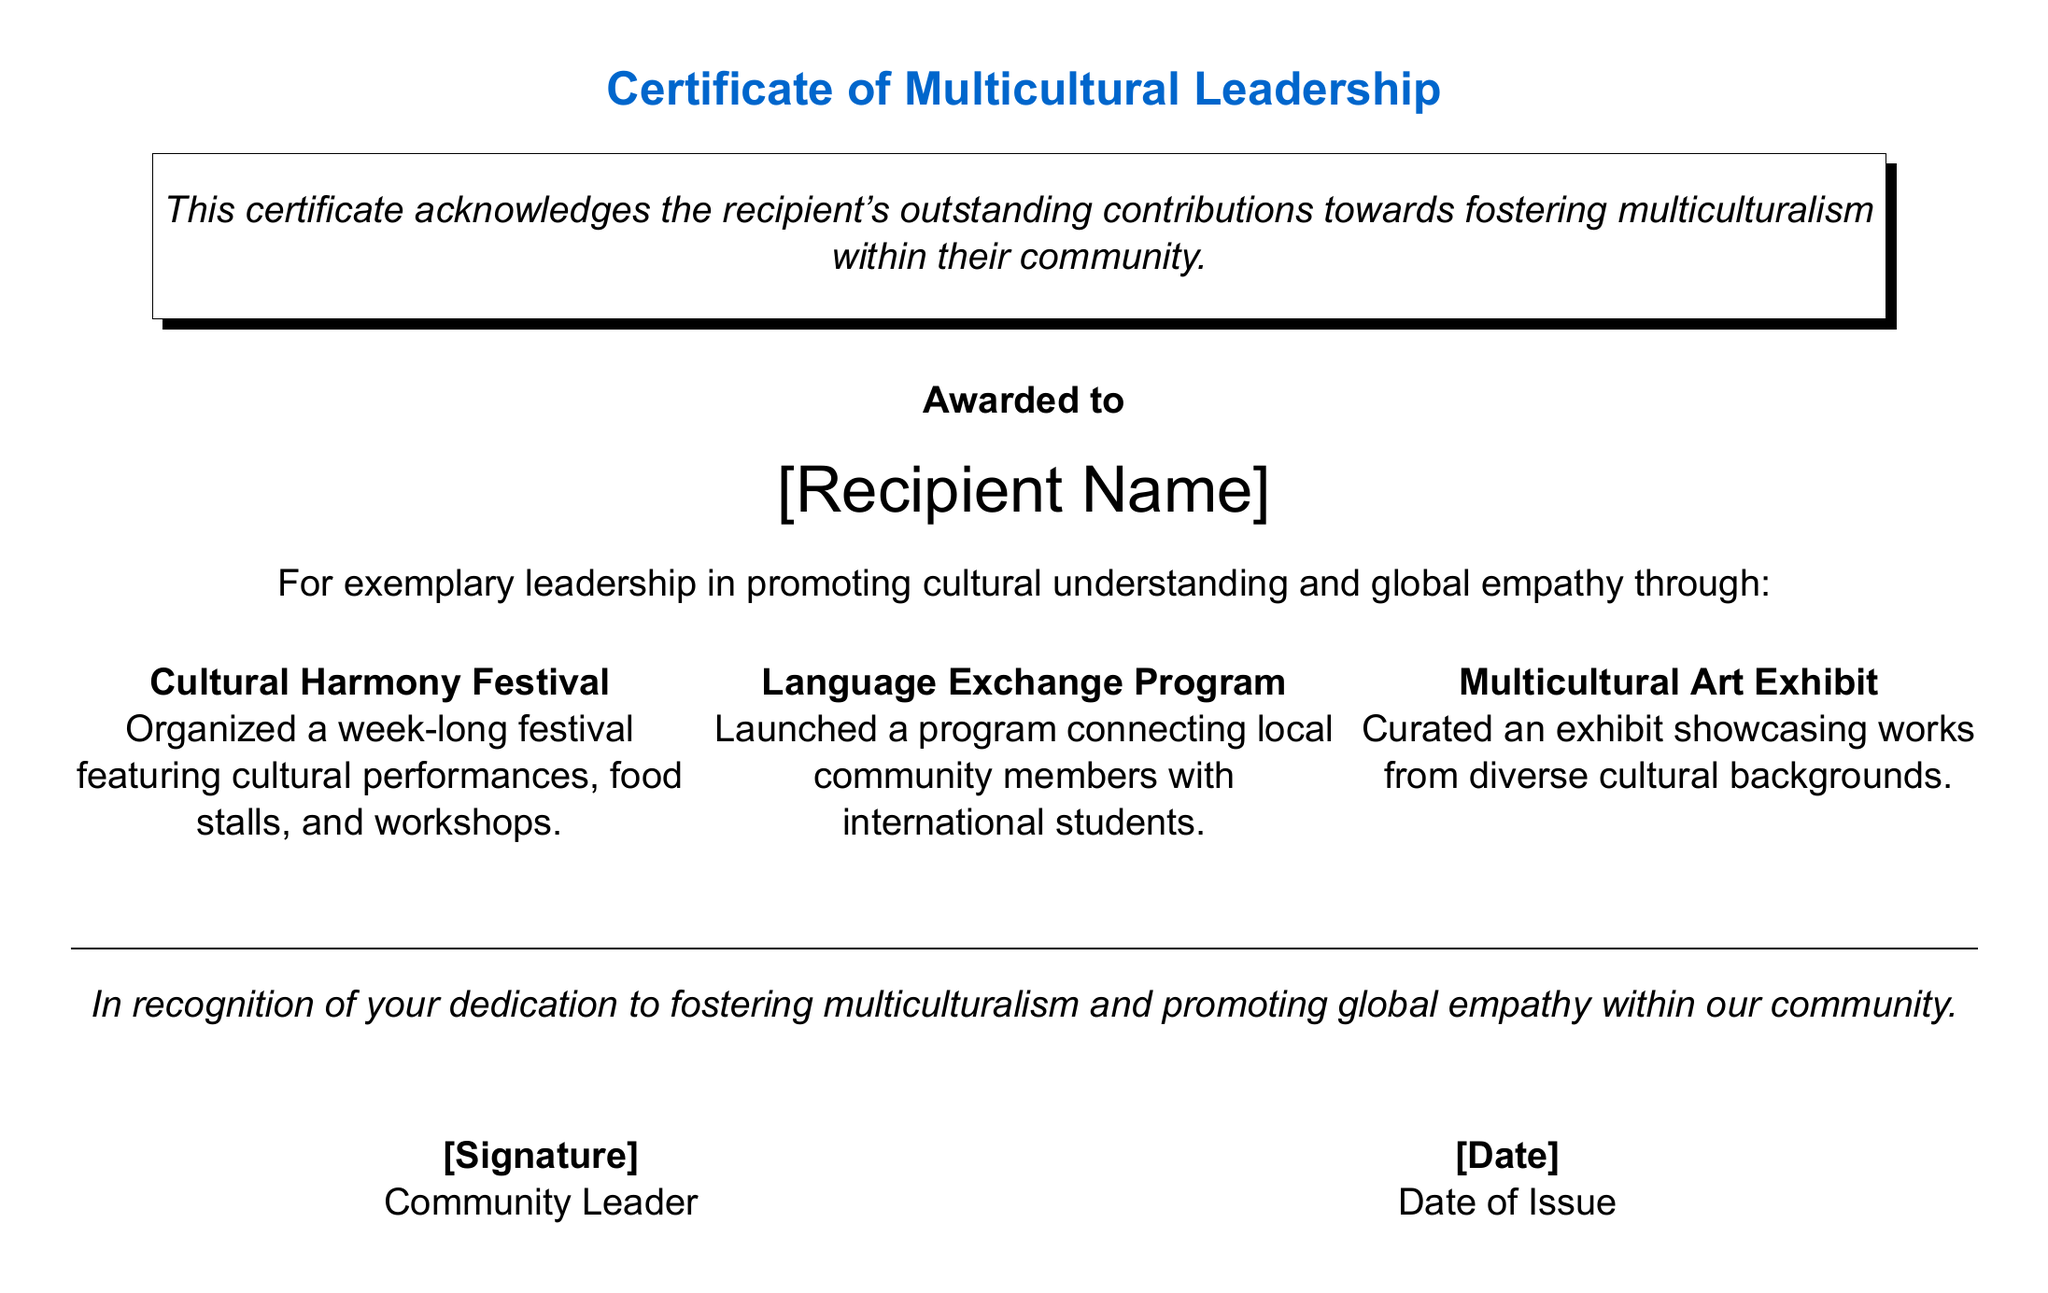What is the title of the certificate? The title is stated at the top of the certificate as "Certificate of Multicultural Leadership."
Answer: Certificate of Multicultural Leadership Who is the recipient of this certificate? The recipient's name is to be filled in the designated area marked as "[Recipient Name]."
Answer: [Recipient Name] What is one event mentioned in the contributions? The document lists several contributions, one of which is the "Cultural Harmony Festival."
Answer: Cultural Harmony Festival What is the purpose of the certificate? The certificate acknowledges contributions towards fostering multiculturalism within the community.
Answer: Fostering multiculturalism Who awards the certificate? The certificate is awarded by a person referred to as "Community Leader."
Answer: Community Leader What specific program did the recipient launch? The document mentions a "Language Exchange Program" as a specific initiative launched by the recipient.
Answer: Language Exchange Program What kind of exhibit did the recipient curate? The document states that the recipient curated a "Multicultural Art Exhibit."
Answer: Multicultural Art Exhibit What type of design element is used to frame the text? The text is framed using a "shadowbox," giving it a distinct visual element.
Answer: Shadowbox What is stated at the bottom of the certificate? At the bottom, it includes spaces for a signature and the date of issue, labeled as "[Signature]" and "[Date]."
Answer: [Signature] and [Date] 